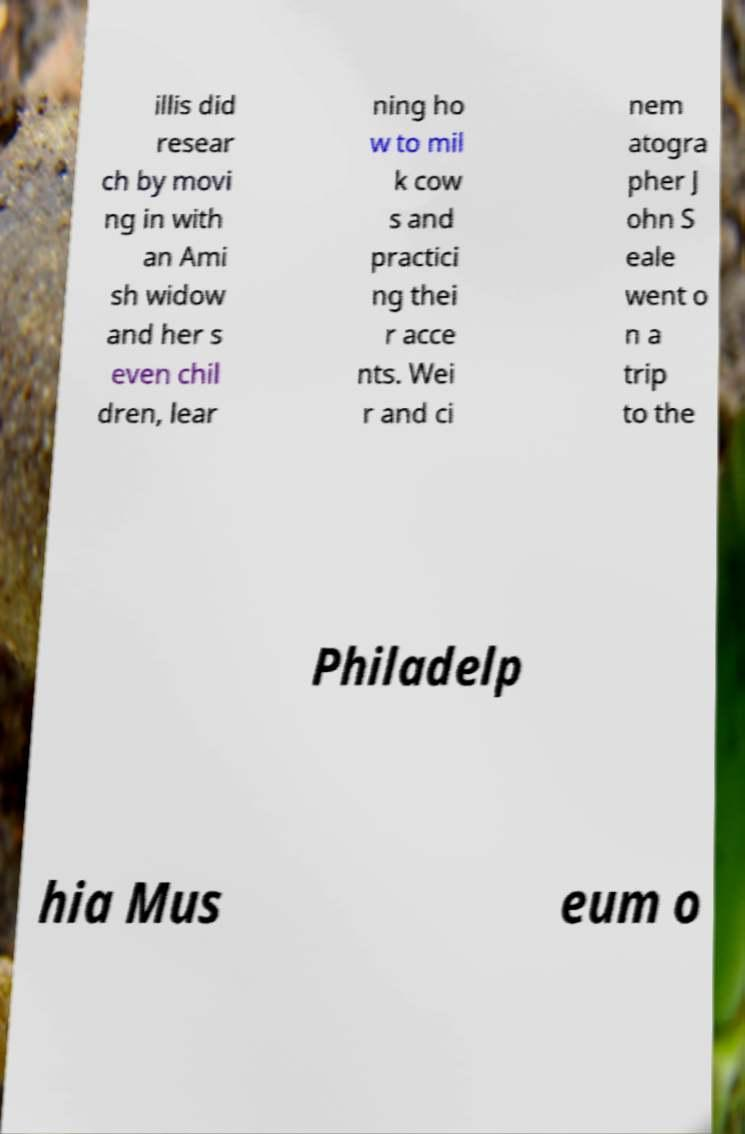Can you accurately transcribe the text from the provided image for me? illis did resear ch by movi ng in with an Ami sh widow and her s even chil dren, lear ning ho w to mil k cow s and practici ng thei r acce nts. Wei r and ci nem atogra pher J ohn S eale went o n a trip to the Philadelp hia Mus eum o 